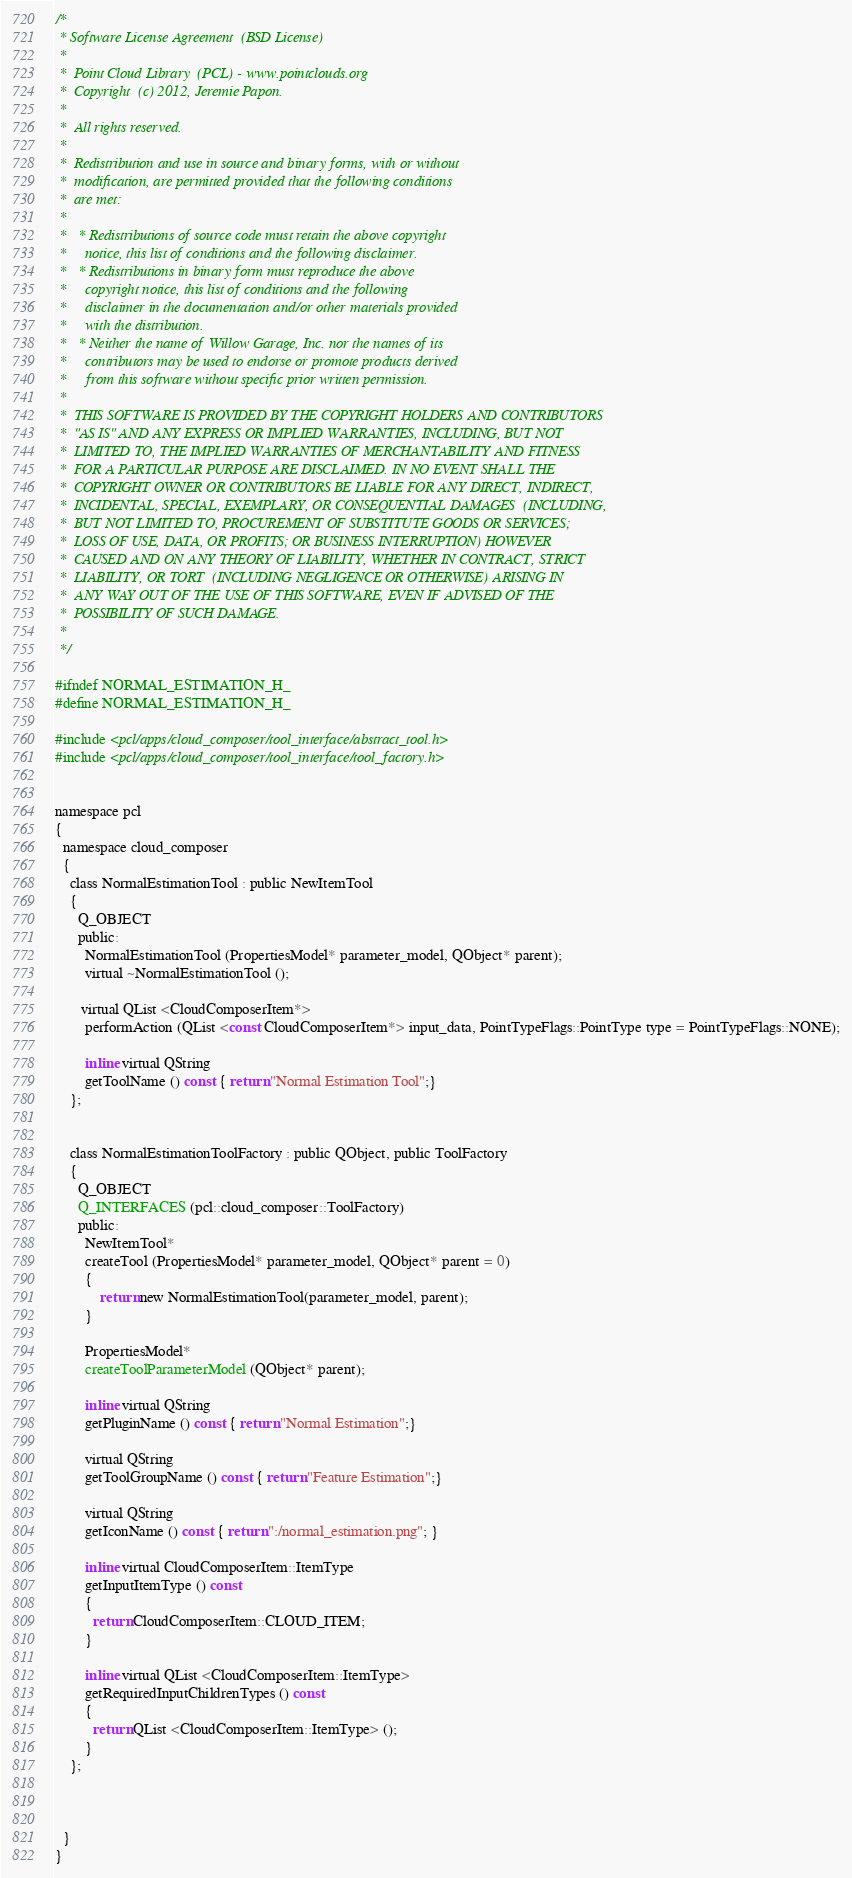<code> <loc_0><loc_0><loc_500><loc_500><_C_>/*
 * Software License Agreement  (BSD License)
 *
 *  Point Cloud Library  (PCL) - www.pointclouds.org
 *  Copyright  (c) 2012, Jeremie Papon.
 *
 *  All rights reserved.
 *
 *  Redistribution and use in source and binary forms, with or without
 *  modification, are permitted provided that the following conditions
 *  are met:
 *
 *   * Redistributions of source code must retain the above copyright
 *     notice, this list of conditions and the following disclaimer.
 *   * Redistributions in binary form must reproduce the above
 *     copyright notice, this list of conditions and the following
 *     disclaimer in the documentation and/or other materials provided
 *     with the distribution.
 *   * Neither the name of Willow Garage, Inc. nor the names of its
 *     contributors may be used to endorse or promote products derived
 *     from this software without specific prior written permission.
 *
 *  THIS SOFTWARE IS PROVIDED BY THE COPYRIGHT HOLDERS AND CONTRIBUTORS
 *  "AS IS" AND ANY EXPRESS OR IMPLIED WARRANTIES, INCLUDING, BUT NOT
 *  LIMITED TO, THE IMPLIED WARRANTIES OF MERCHANTABILITY AND FITNESS
 *  FOR A PARTICULAR PURPOSE ARE DISCLAIMED. IN NO EVENT SHALL THE
 *  COPYRIGHT OWNER OR CONTRIBUTORS BE LIABLE FOR ANY DIRECT, INDIRECT,
 *  INCIDENTAL, SPECIAL, EXEMPLARY, OR CONSEQUENTIAL DAMAGES  (INCLUDING,
 *  BUT NOT LIMITED TO, PROCUREMENT OF SUBSTITUTE GOODS OR SERVICES;
 *  LOSS OF USE, DATA, OR PROFITS; OR BUSINESS INTERRUPTION) HOWEVER
 *  CAUSED AND ON ANY THEORY OF LIABILITY, WHETHER IN CONTRACT, STRICT
 *  LIABILITY, OR TORT  (INCLUDING NEGLIGENCE OR OTHERWISE) ARISING IN
 *  ANY WAY OUT OF THE USE OF THIS SOFTWARE, EVEN IF ADVISED OF THE
 *  POSSIBILITY OF SUCH DAMAGE.
 *
 */

#ifndef NORMAL_ESTIMATION_H_
#define NORMAL_ESTIMATION_H_

#include <pcl/apps/cloud_composer/tool_interface/abstract_tool.h>
#include <pcl/apps/cloud_composer/tool_interface/tool_factory.h>


namespace pcl
{
  namespace cloud_composer
  {
    class NormalEstimationTool : public NewItemTool
    {
      Q_OBJECT
      public:
        NormalEstimationTool (PropertiesModel* parameter_model, QObject* parent);
        virtual ~NormalEstimationTool ();
        
       virtual QList <CloudComposerItem*>
        performAction (QList <const CloudComposerItem*> input_data, PointTypeFlags::PointType type = PointTypeFlags::NONE);
      
        inline virtual QString
        getToolName () const { return "Normal Estimation Tool";}
    };

    
    class NormalEstimationToolFactory : public QObject, public ToolFactory
    {
      Q_OBJECT
      Q_INTERFACES (pcl::cloud_composer::ToolFactory)
      public:
        NewItemTool*
        createTool (PropertiesModel* parameter_model, QObject* parent = 0) 
        {
            return new NormalEstimationTool(parameter_model, parent);
        }
        
        PropertiesModel*
        createToolParameterModel (QObject* parent);
        
        inline virtual QString 
        getPluginName () const { return "Normal Estimation";}
        
        virtual QString 
        getToolGroupName () const { return "Feature Estimation";}
        
        virtual QString
        getIconName () const { return ":/normal_estimation.png"; }
        
        inline virtual CloudComposerItem::ItemType
        getInputItemType () const
        {
          return CloudComposerItem::CLOUD_ITEM;
        }
        
        inline virtual QList <CloudComposerItem::ItemType>
        getRequiredInputChildrenTypes () const 
        {
          return QList <CloudComposerItem::ItemType> ();
        }
    };



  }
}
</code> 